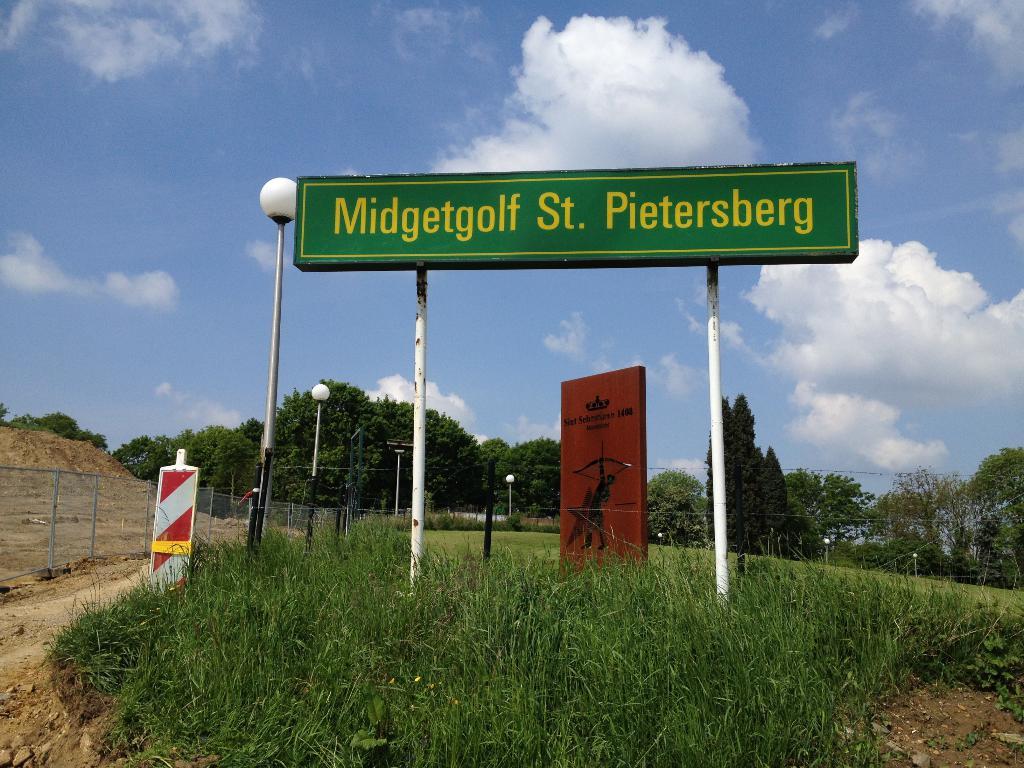What is the number on the brown sign?
Provide a succinct answer. Unanswerable. 